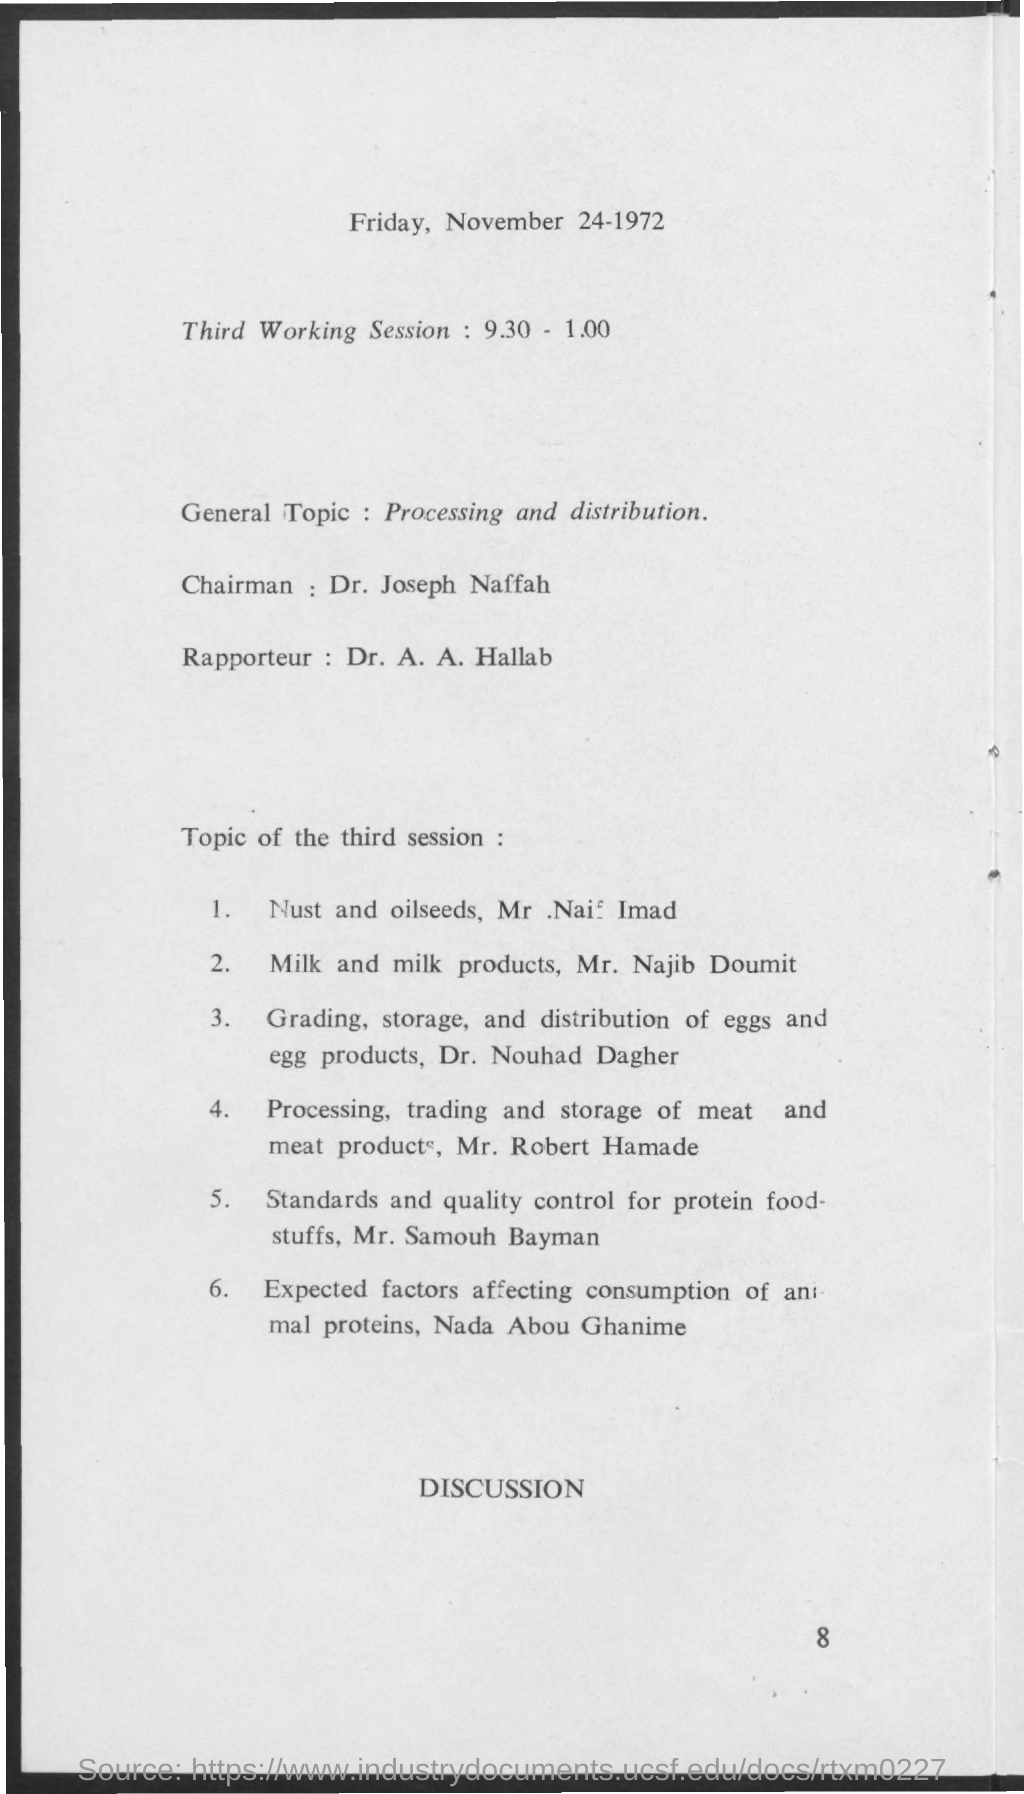Outline some significant characteristics in this image. The general topic mentioned is "Processing and Distribution. The given page mentions that the date is Friday, November 24, 1972. The chairman's name is Dr. Joseph Naffah. 